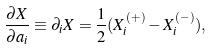Convert formula to latex. <formula><loc_0><loc_0><loc_500><loc_500>\frac { \partial X } { \partial a _ { i } } \equiv \partial _ { i } X = \frac { 1 } { 2 } ( X _ { i } ^ { ( + ) } - X _ { i } ^ { ( - ) } ) ,</formula> 